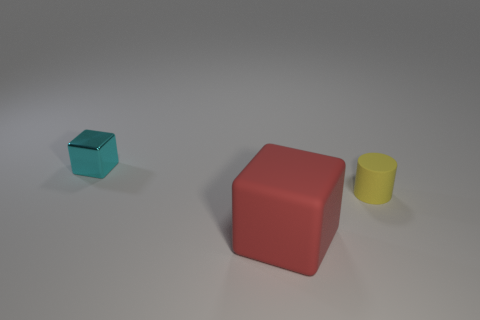Add 1 yellow rubber cubes. How many objects exist? 4 Subtract all blocks. How many objects are left? 1 Subtract all small yellow things. Subtract all large red things. How many objects are left? 1 Add 2 cyan metal cubes. How many cyan metal cubes are left? 3 Add 1 yellow rubber objects. How many yellow rubber objects exist? 2 Subtract 0 red balls. How many objects are left? 3 